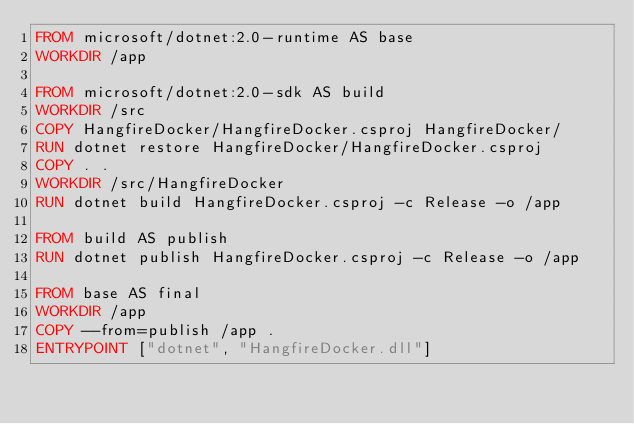Convert code to text. <code><loc_0><loc_0><loc_500><loc_500><_Dockerfile_>FROM microsoft/dotnet:2.0-runtime AS base
WORKDIR /app

FROM microsoft/dotnet:2.0-sdk AS build
WORKDIR /src
COPY HangfireDocker/HangfireDocker.csproj HangfireDocker/
RUN dotnet restore HangfireDocker/HangfireDocker.csproj
COPY . .
WORKDIR /src/HangfireDocker
RUN dotnet build HangfireDocker.csproj -c Release -o /app

FROM build AS publish
RUN dotnet publish HangfireDocker.csproj -c Release -o /app

FROM base AS final
WORKDIR /app
COPY --from=publish /app .
ENTRYPOINT ["dotnet", "HangfireDocker.dll"]
</code> 